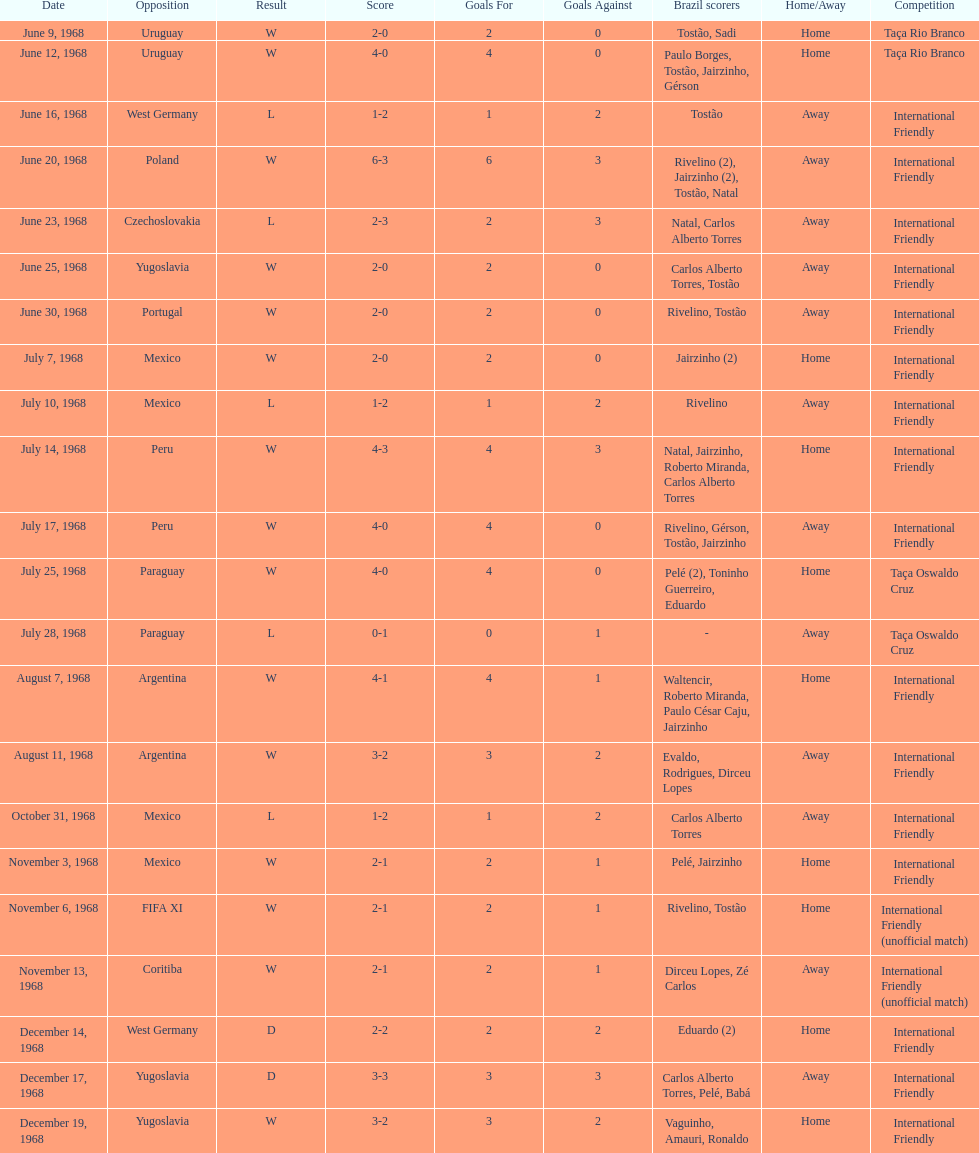What is the number of countries they have played? 11. 